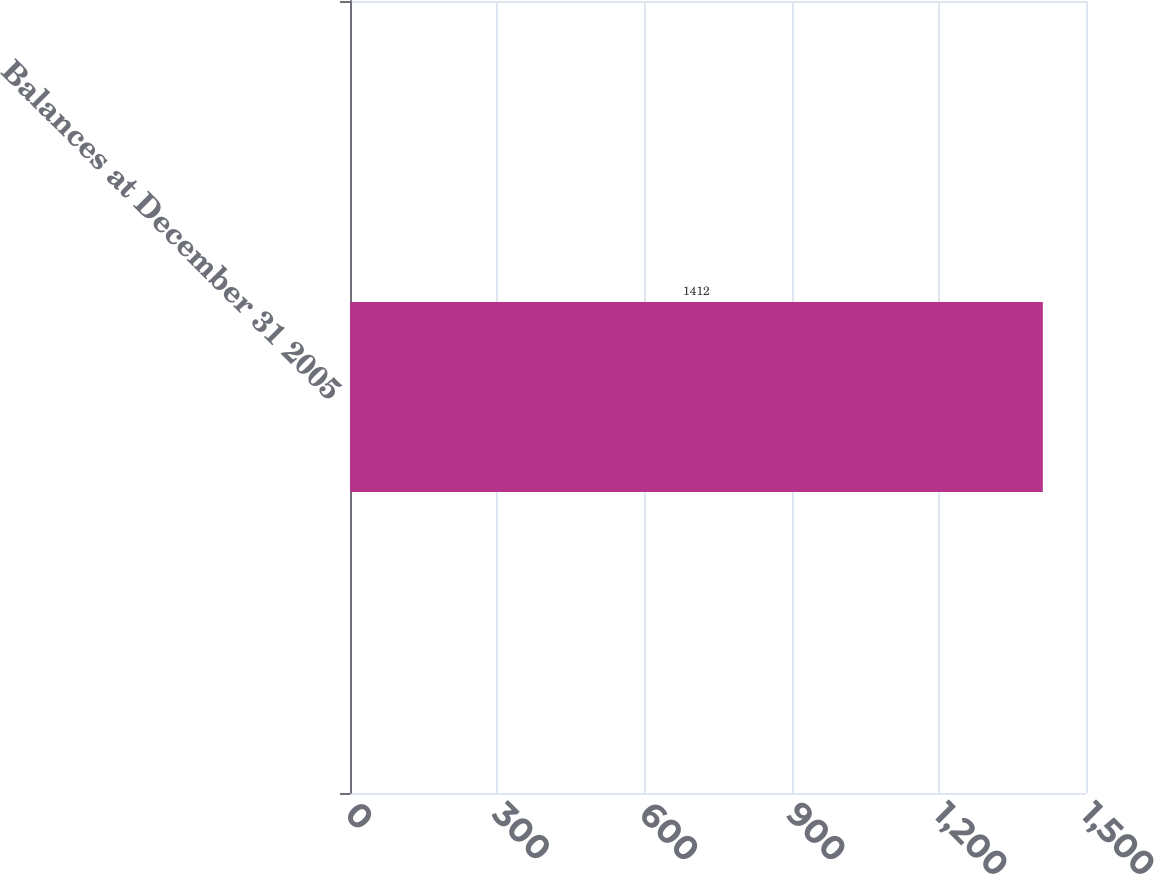Convert chart. <chart><loc_0><loc_0><loc_500><loc_500><bar_chart><fcel>Balances at December 31 2005<nl><fcel>1412<nl></chart> 